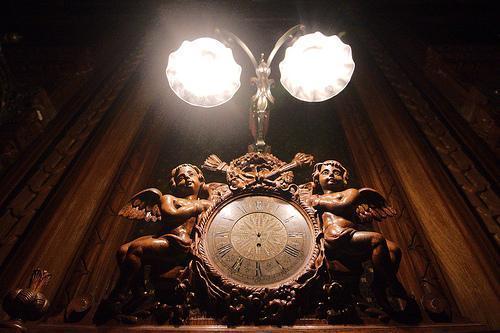How many lights are above the clock?
Give a very brief answer. 2. How many cherubs are holding the clock?
Give a very brief answer. 2. How many angels are in this photo?
Give a very brief answer. 2. How many clocks are in this picture?
Give a very brief answer. 1. How many people are in this picture?
Give a very brief answer. 0. How many lights are in this picture?
Give a very brief answer. 2. 